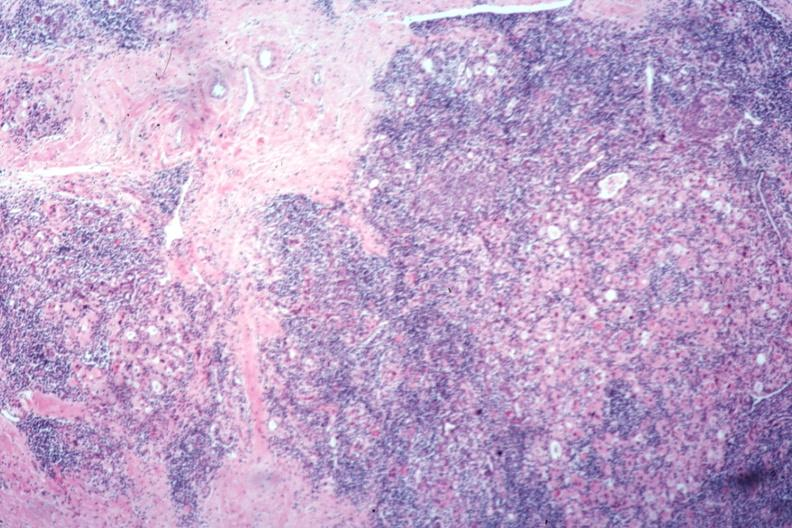where is this part in the figure?
Answer the question using a single word or phrase. Endocrine system 